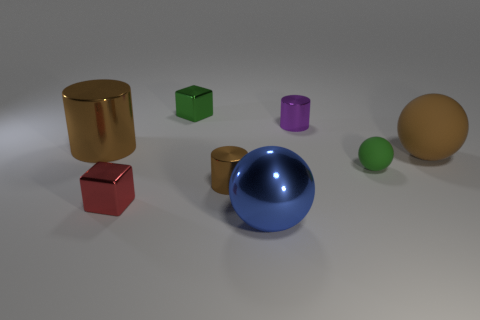Subtract all yellow cubes. How many brown cylinders are left? 2 Subtract all large metal cylinders. How many cylinders are left? 2 Subtract 1 balls. How many balls are left? 2 Add 1 red rubber spheres. How many objects exist? 9 Subtract all red balls. Subtract all brown cylinders. How many balls are left? 3 Subtract all cubes. How many objects are left? 6 Subtract all tiny purple metal things. Subtract all small things. How many objects are left? 2 Add 8 large brown rubber objects. How many large brown rubber objects are left? 9 Add 6 big green matte cylinders. How many big green matte cylinders exist? 6 Subtract 0 purple balls. How many objects are left? 8 